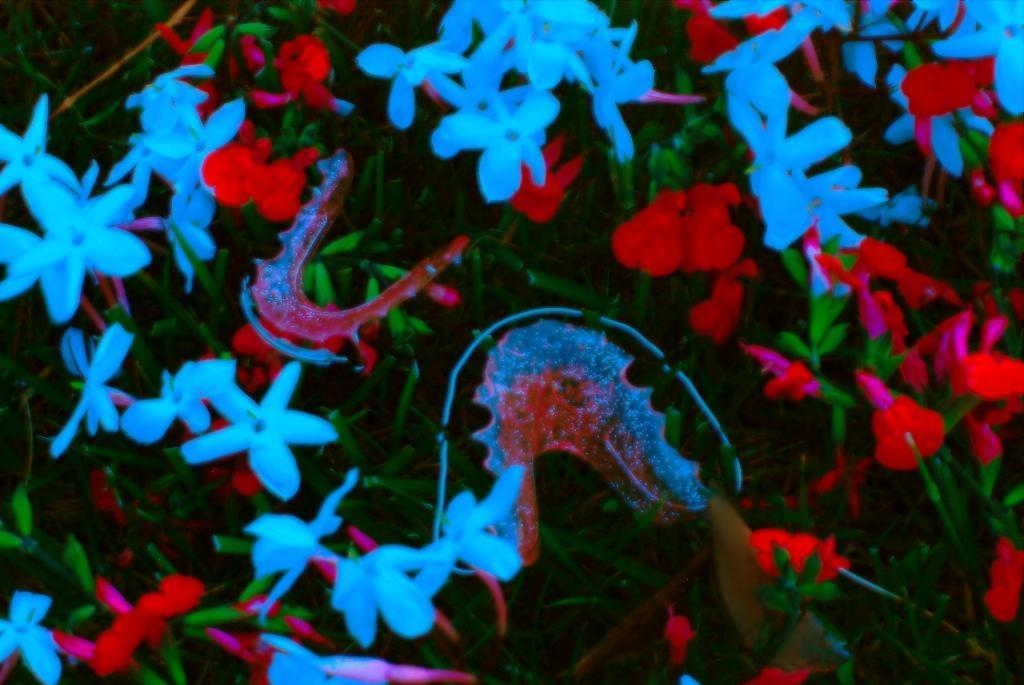What type of plants are present in the image? There are flower plants in the image. What can be found on the flower plants? There are flowers on the plants. What colors are the flowers? The flowers are white and red in color. What type of vegetable is being used to make the eggnog in the image? There is no eggnog or vegetable present in the image; it features flower plants with white and red flowers. 